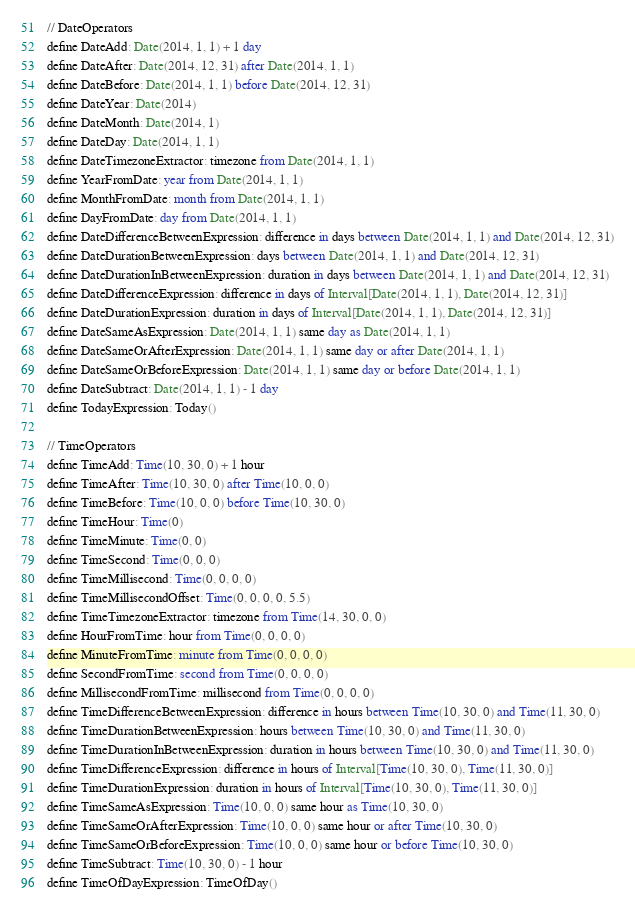Convert code to text. <code><loc_0><loc_0><loc_500><loc_500><_SQL_>// DateOperators
define DateAdd: Date(2014, 1, 1) + 1 day
define DateAfter: Date(2014, 12, 31) after Date(2014, 1, 1)
define DateBefore: Date(2014, 1, 1) before Date(2014, 12, 31)
define DateYear: Date(2014)
define DateMonth: Date(2014, 1)
define DateDay: Date(2014, 1, 1)
define DateTimezoneExtractor: timezone from Date(2014, 1, 1)
define YearFromDate: year from Date(2014, 1, 1)
define MonthFromDate: month from Date(2014, 1, 1)
define DayFromDate: day from Date(2014, 1, 1)
define DateDifferenceBetweenExpression: difference in days between Date(2014, 1, 1) and Date(2014, 12, 31)
define DateDurationBetweenExpression: days between Date(2014, 1, 1) and Date(2014, 12, 31)
define DateDurationInBetweenExpression: duration in days between Date(2014, 1, 1) and Date(2014, 12, 31)
define DateDifferenceExpression: difference in days of Interval[Date(2014, 1, 1), Date(2014, 12, 31)]
define DateDurationExpression: duration in days of Interval[Date(2014, 1, 1), Date(2014, 12, 31)]
define DateSameAsExpression: Date(2014, 1, 1) same day as Date(2014, 1, 1)
define DateSameOrAfterExpression: Date(2014, 1, 1) same day or after Date(2014, 1, 1)
define DateSameOrBeforeExpression: Date(2014, 1, 1) same day or before Date(2014, 1, 1)
define DateSubtract: Date(2014, 1, 1) - 1 day
define TodayExpression: Today()

// TimeOperators
define TimeAdd: Time(10, 30, 0) + 1 hour
define TimeAfter: Time(10, 30, 0) after Time(10, 0, 0)
define TimeBefore: Time(10, 0, 0) before Time(10, 30, 0)
define TimeHour: Time(0)
define TimeMinute: Time(0, 0)
define TimeSecond: Time(0, 0, 0)
define TimeMillisecond: Time(0, 0, 0, 0)
define TimeMillisecondOffset: Time(0, 0, 0, 0, 5.5)
define TimeTimezoneExtractor: timezone from Time(14, 30, 0, 0)
define HourFromTime: hour from Time(0, 0, 0, 0)
define MinuteFromTime: minute from Time(0, 0, 0, 0)
define SecondFromTime: second from Time(0, 0, 0, 0)
define MillisecondFromTime: millisecond from Time(0, 0, 0, 0)
define TimeDifferenceBetweenExpression: difference in hours between Time(10, 30, 0) and Time(11, 30, 0)
define TimeDurationBetweenExpression: hours between Time(10, 30, 0) and Time(11, 30, 0)
define TimeDurationInBetweenExpression: duration in hours between Time(10, 30, 0) and Time(11, 30, 0)
define TimeDifferenceExpression: difference in hours of Interval[Time(10, 30, 0), Time(11, 30, 0)]
define TimeDurationExpression: duration in hours of Interval[Time(10, 30, 0), Time(11, 30, 0)]
define TimeSameAsExpression: Time(10, 0, 0) same hour as Time(10, 30, 0)
define TimeSameOrAfterExpression: Time(10, 0, 0) same hour or after Time(10, 30, 0)
define TimeSameOrBeforeExpression: Time(10, 0, 0) same hour or before Time(10, 30, 0)
define TimeSubtract: Time(10, 30, 0) - 1 hour
define TimeOfDayExpression: TimeOfDay()
</code> 